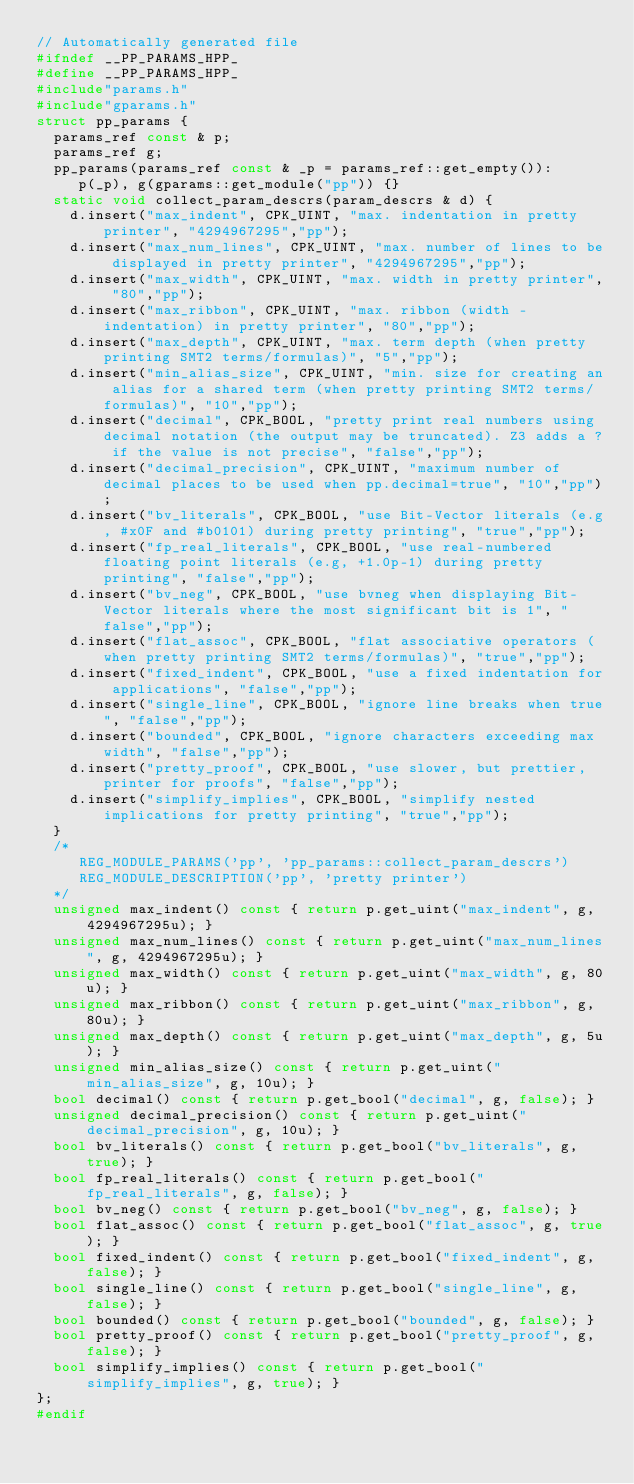Convert code to text. <code><loc_0><loc_0><loc_500><loc_500><_C++_>// Automatically generated file
#ifndef __PP_PARAMS_HPP_
#define __PP_PARAMS_HPP_
#include"params.h"
#include"gparams.h"
struct pp_params {
  params_ref const & p;
  params_ref g;
  pp_params(params_ref const & _p = params_ref::get_empty()):
     p(_p), g(gparams::get_module("pp")) {}
  static void collect_param_descrs(param_descrs & d) {
    d.insert("max_indent", CPK_UINT, "max. indentation in pretty printer", "4294967295","pp");
    d.insert("max_num_lines", CPK_UINT, "max. number of lines to be displayed in pretty printer", "4294967295","pp");
    d.insert("max_width", CPK_UINT, "max. width in pretty printer", "80","pp");
    d.insert("max_ribbon", CPK_UINT, "max. ribbon (width - indentation) in pretty printer", "80","pp");
    d.insert("max_depth", CPK_UINT, "max. term depth (when pretty printing SMT2 terms/formulas)", "5","pp");
    d.insert("min_alias_size", CPK_UINT, "min. size for creating an alias for a shared term (when pretty printing SMT2 terms/formulas)", "10","pp");
    d.insert("decimal", CPK_BOOL, "pretty print real numbers using decimal notation (the output may be truncated). Z3 adds a ? if the value is not precise", "false","pp");
    d.insert("decimal_precision", CPK_UINT, "maximum number of decimal places to be used when pp.decimal=true", "10","pp");
    d.insert("bv_literals", CPK_BOOL, "use Bit-Vector literals (e.g, #x0F and #b0101) during pretty printing", "true","pp");
    d.insert("fp_real_literals", CPK_BOOL, "use real-numbered floating point literals (e.g, +1.0p-1) during pretty printing", "false","pp");
    d.insert("bv_neg", CPK_BOOL, "use bvneg when displaying Bit-Vector literals where the most significant bit is 1", "false","pp");
    d.insert("flat_assoc", CPK_BOOL, "flat associative operators (when pretty printing SMT2 terms/formulas)", "true","pp");
    d.insert("fixed_indent", CPK_BOOL, "use a fixed indentation for applications", "false","pp");
    d.insert("single_line", CPK_BOOL, "ignore line breaks when true", "false","pp");
    d.insert("bounded", CPK_BOOL, "ignore characters exceeding max width", "false","pp");
    d.insert("pretty_proof", CPK_BOOL, "use slower, but prettier, printer for proofs", "false","pp");
    d.insert("simplify_implies", CPK_BOOL, "simplify nested implications for pretty printing", "true","pp");
  }
  /*
     REG_MODULE_PARAMS('pp', 'pp_params::collect_param_descrs')
     REG_MODULE_DESCRIPTION('pp', 'pretty printer')
  */
  unsigned max_indent() const { return p.get_uint("max_indent", g, 4294967295u); }
  unsigned max_num_lines() const { return p.get_uint("max_num_lines", g, 4294967295u); }
  unsigned max_width() const { return p.get_uint("max_width", g, 80u); }
  unsigned max_ribbon() const { return p.get_uint("max_ribbon", g, 80u); }
  unsigned max_depth() const { return p.get_uint("max_depth", g, 5u); }
  unsigned min_alias_size() const { return p.get_uint("min_alias_size", g, 10u); }
  bool decimal() const { return p.get_bool("decimal", g, false); }
  unsigned decimal_precision() const { return p.get_uint("decimal_precision", g, 10u); }
  bool bv_literals() const { return p.get_bool("bv_literals", g, true); }
  bool fp_real_literals() const { return p.get_bool("fp_real_literals", g, false); }
  bool bv_neg() const { return p.get_bool("bv_neg", g, false); }
  bool flat_assoc() const { return p.get_bool("flat_assoc", g, true); }
  bool fixed_indent() const { return p.get_bool("fixed_indent", g, false); }
  bool single_line() const { return p.get_bool("single_line", g, false); }
  bool bounded() const { return p.get_bool("bounded", g, false); }
  bool pretty_proof() const { return p.get_bool("pretty_proof", g, false); }
  bool simplify_implies() const { return p.get_bool("simplify_implies", g, true); }
};
#endif
</code> 